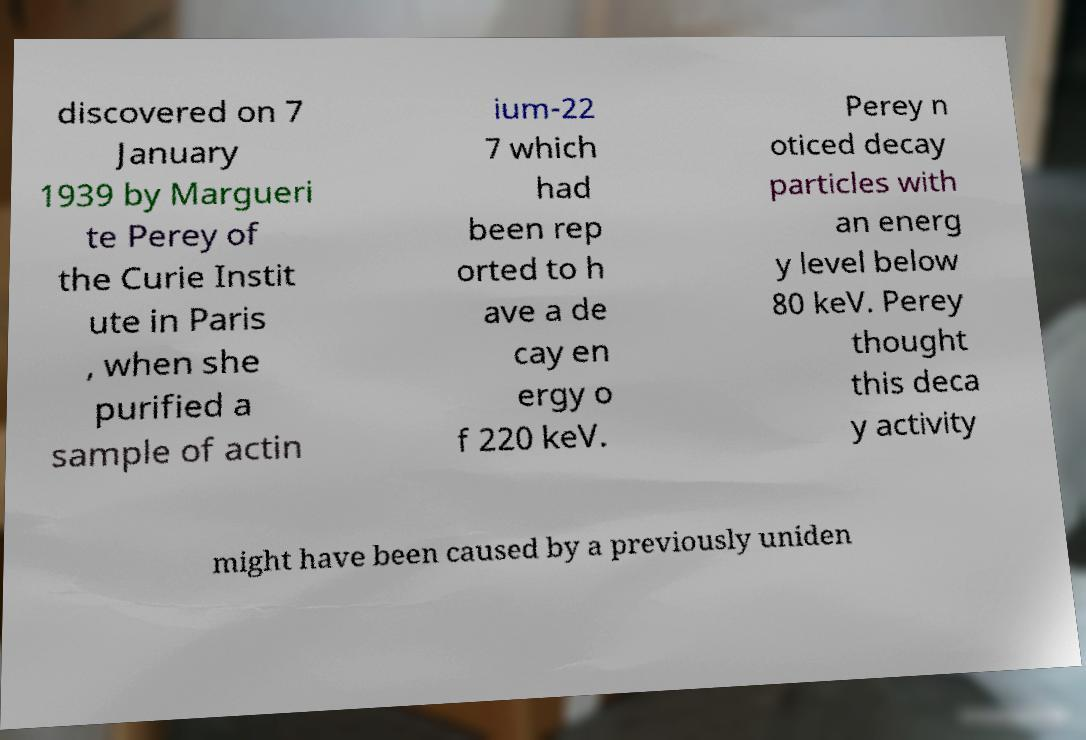Please read and relay the text visible in this image. What does it say? discovered on 7 January 1939 by Margueri te Perey of the Curie Instit ute in Paris , when she purified a sample of actin ium-22 7 which had been rep orted to h ave a de cay en ergy o f 220 keV. Perey n oticed decay particles with an energ y level below 80 keV. Perey thought this deca y activity might have been caused by a previously uniden 